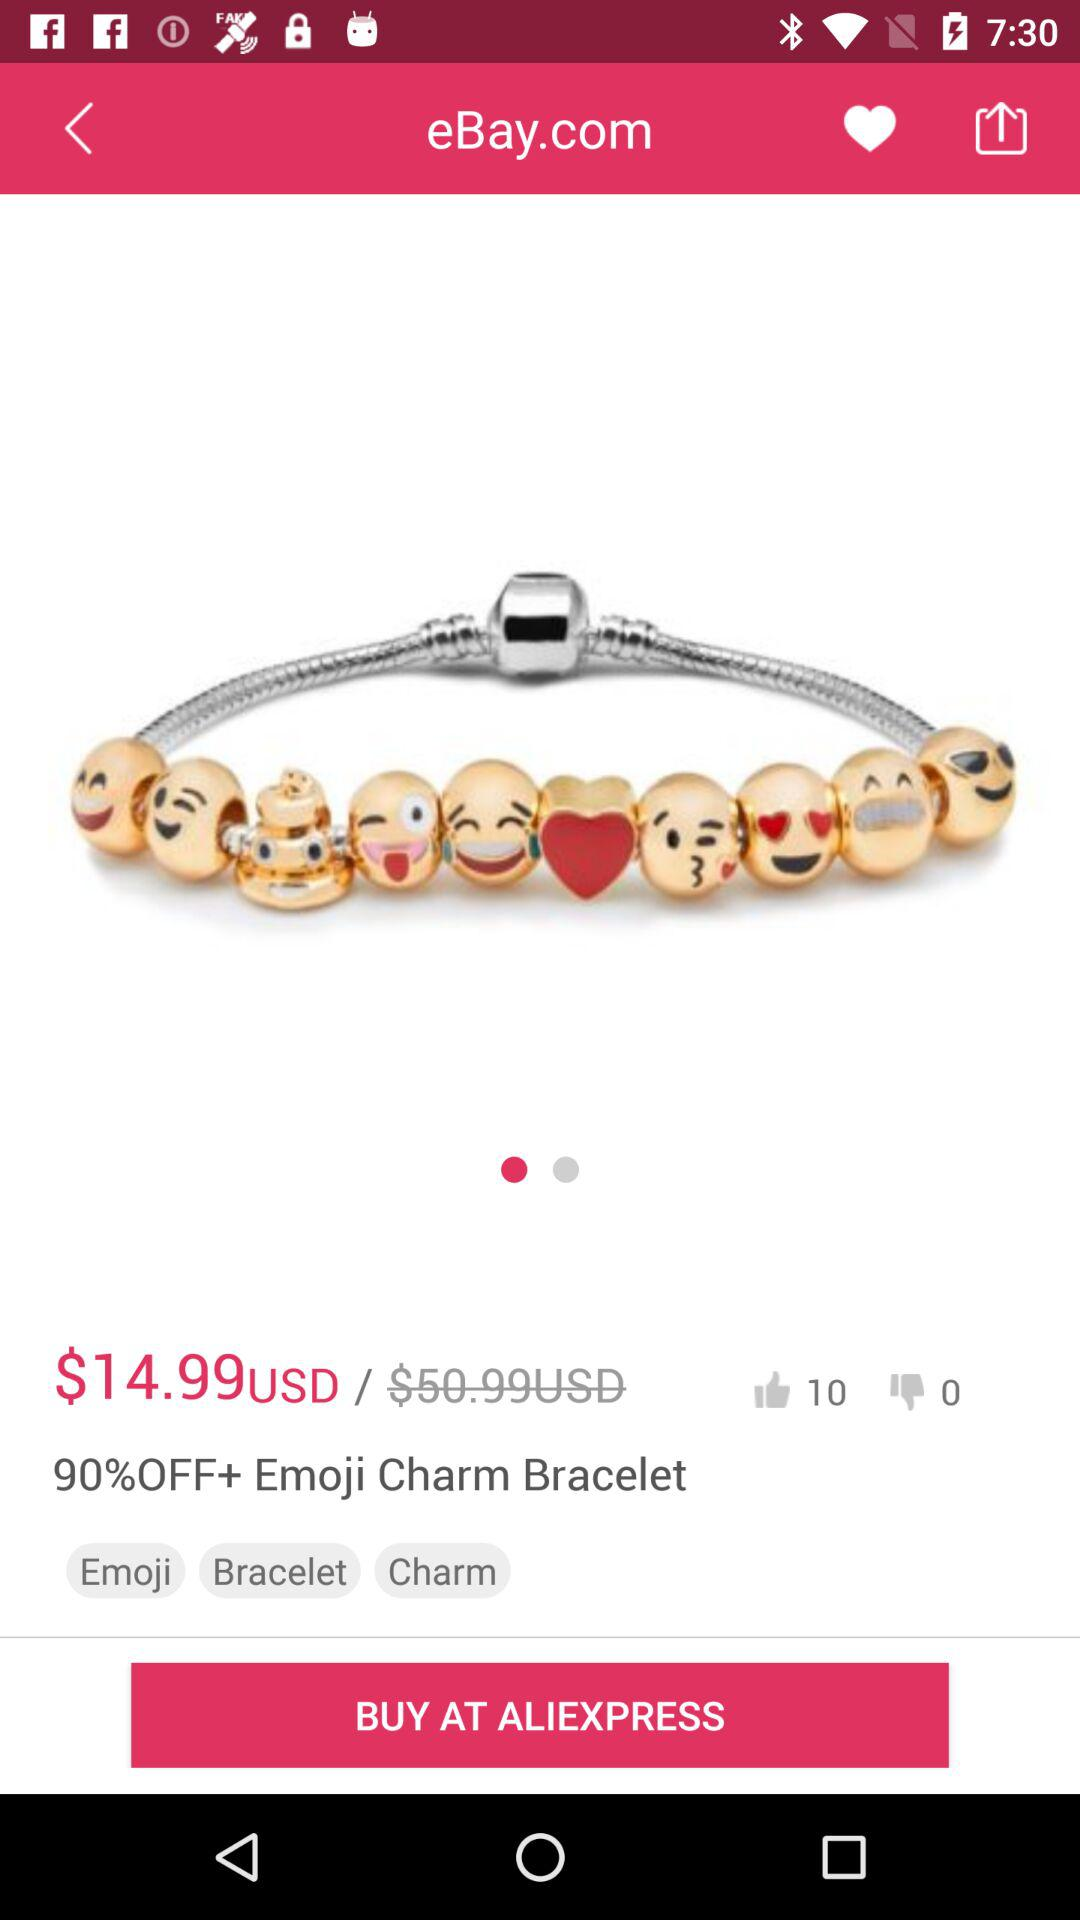How many more people have given this product a thumbs up than a thumbs down?
Answer the question using a single word or phrase. 10 